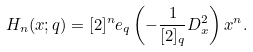<formula> <loc_0><loc_0><loc_500><loc_500>H _ { n } ( x ; q ) = [ 2 ] ^ { n } e _ { q } \left ( - \frac { 1 } { [ 2 ] _ { q } } D ^ { 2 } _ { x } \right ) x ^ { n } .</formula> 